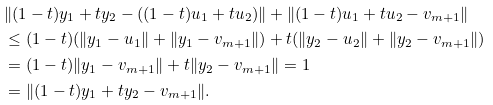Convert formula to latex. <formula><loc_0><loc_0><loc_500><loc_500>& \| ( 1 - t ) y _ { 1 } + t y _ { 2 } - ( ( 1 - t ) u _ { 1 } + t u _ { 2 } ) \| + \| ( 1 - t ) u _ { 1 } + t u _ { 2 } - v _ { m + 1 } \| \\ & \leq ( 1 - t ) ( \| y _ { 1 } - u _ { 1 } \| + \| y _ { 1 } - v _ { m + 1 } \| ) + t ( \| y _ { 2 } - u _ { 2 } \| + \| y _ { 2 } - v _ { m + 1 } \| ) \\ & = ( 1 - t ) \| y _ { 1 } - v _ { m + 1 } \| + t \| y _ { 2 } - v _ { m + 1 } \| = 1 \\ & = \| ( 1 - t ) y _ { 1 } + t y _ { 2 } - v _ { m + 1 } \| .</formula> 